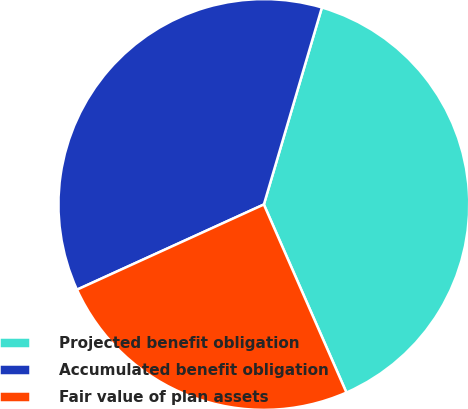Convert chart to OTSL. <chart><loc_0><loc_0><loc_500><loc_500><pie_chart><fcel>Projected benefit obligation<fcel>Accumulated benefit obligation<fcel>Fair value of plan assets<nl><fcel>38.86%<fcel>36.37%<fcel>24.78%<nl></chart> 